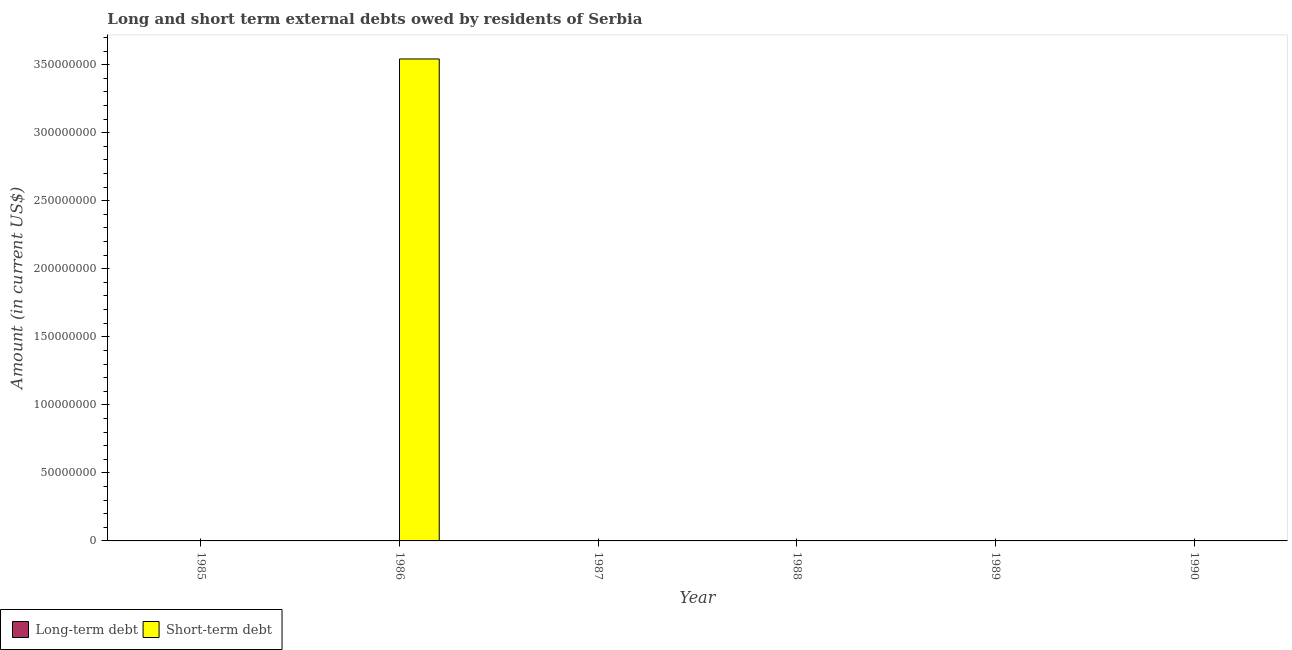How many different coloured bars are there?
Ensure brevity in your answer.  1. Are the number of bars on each tick of the X-axis equal?
Offer a terse response. No. How many bars are there on the 5th tick from the right?
Make the answer very short. 1. What is the short-term debts owed by residents in 1986?
Offer a very short reply. 3.54e+08. Across all years, what is the maximum short-term debts owed by residents?
Offer a terse response. 3.54e+08. In which year was the short-term debts owed by residents maximum?
Make the answer very short. 1986. What is the total long-term debts owed by residents in the graph?
Provide a succinct answer. 0. What is the difference between the long-term debts owed by residents in 1986 and the short-term debts owed by residents in 1987?
Offer a terse response. 0. What is the average short-term debts owed by residents per year?
Keep it short and to the point. 5.90e+07. In how many years, is the long-term debts owed by residents greater than 180000000 US$?
Give a very brief answer. 0. What is the difference between the highest and the lowest short-term debts owed by residents?
Your answer should be compact. 3.54e+08. How many bars are there?
Offer a very short reply. 1. How many years are there in the graph?
Provide a short and direct response. 6. What is the difference between two consecutive major ticks on the Y-axis?
Provide a short and direct response. 5.00e+07. How many legend labels are there?
Ensure brevity in your answer.  2. What is the title of the graph?
Offer a very short reply. Long and short term external debts owed by residents of Serbia. What is the label or title of the X-axis?
Provide a short and direct response. Year. What is the label or title of the Y-axis?
Provide a succinct answer. Amount (in current US$). What is the Amount (in current US$) of Long-term debt in 1986?
Keep it short and to the point. 0. What is the Amount (in current US$) in Short-term debt in 1986?
Your response must be concise. 3.54e+08. What is the Amount (in current US$) in Short-term debt in 1987?
Provide a succinct answer. 0. What is the Amount (in current US$) of Short-term debt in 1988?
Ensure brevity in your answer.  0. What is the Amount (in current US$) in Long-term debt in 1989?
Provide a succinct answer. 0. What is the Amount (in current US$) in Short-term debt in 1989?
Offer a terse response. 0. What is the Amount (in current US$) of Short-term debt in 1990?
Provide a short and direct response. 0. Across all years, what is the maximum Amount (in current US$) in Short-term debt?
Your response must be concise. 3.54e+08. What is the total Amount (in current US$) of Short-term debt in the graph?
Your answer should be very brief. 3.54e+08. What is the average Amount (in current US$) in Short-term debt per year?
Your answer should be very brief. 5.90e+07. What is the difference between the highest and the lowest Amount (in current US$) in Short-term debt?
Your answer should be compact. 3.54e+08. 